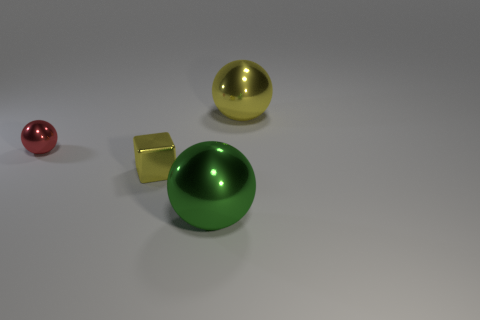Subtract all tiny shiny spheres. How many spheres are left? 2 Add 1 tiny gray blocks. How many objects exist? 5 Subtract all yellow balls. How many balls are left? 2 Subtract all cyan balls. Subtract all red cubes. How many balls are left? 3 Subtract all green things. Subtract all green spheres. How many objects are left? 2 Add 2 tiny cubes. How many tiny cubes are left? 3 Add 1 yellow metallic blocks. How many yellow metallic blocks exist? 2 Subtract 0 blue blocks. How many objects are left? 4 Subtract all cubes. How many objects are left? 3 